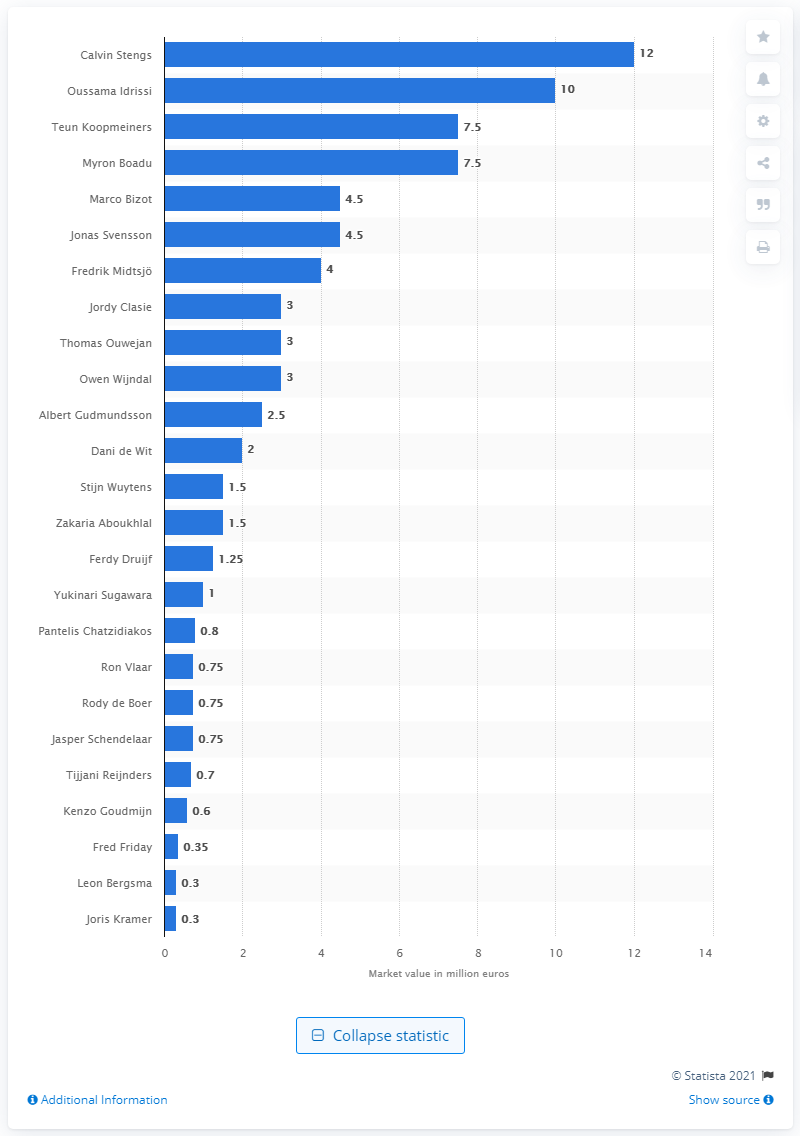Specify some key components in this picture. As of 2019/20, Calvin Stengs was considered to be the player who was worth the most. Oussama Idrissi had a market value of ten million euros. The market value of Teun Koopmeiners and Myron Boadu was 7.5 million dollars. 